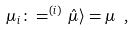Convert formula to latex. <formula><loc_0><loc_0><loc_500><loc_500>\mu _ { i } \colon = ^ { ( i ) } \, \hat { \mu } \rangle = \mu \ ,</formula> 